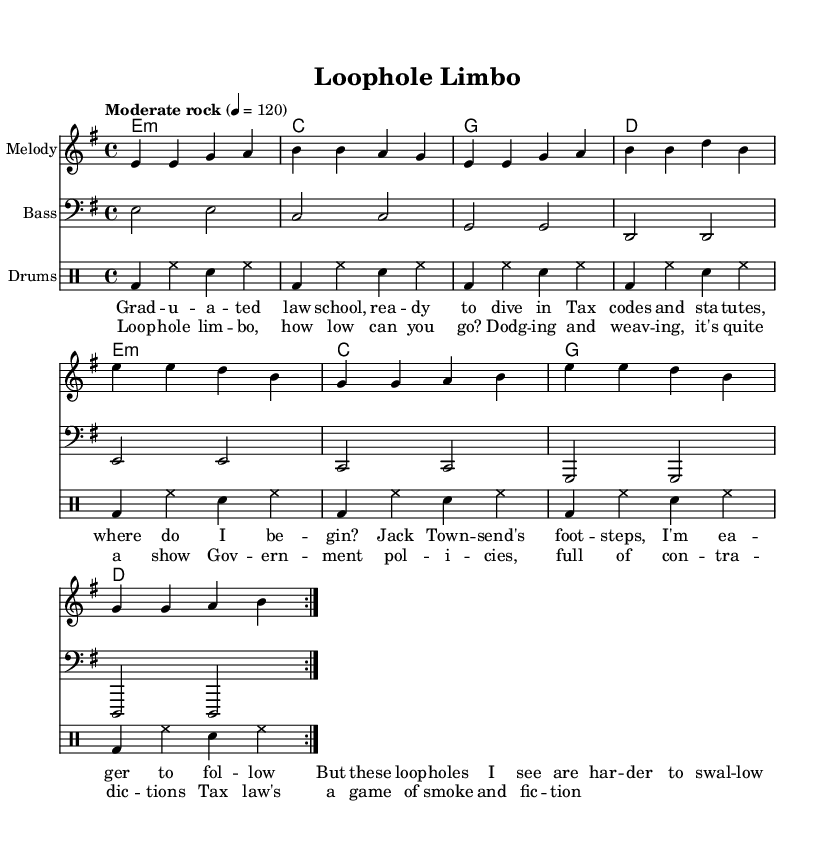What is the key signature of this music? The key signature shown in the music is E minor, which has one sharp (F#). This can be identified from the key signature notation at the beginning of the staff.
Answer: E minor What is the time signature of this piece? The time signature indicated in the sheet music is 4/4, which is shown at the beginning next to the key signature. This means there are four beats in a measure, and a quarter note gets one beat.
Answer: 4/4 What is the tempo marking for this song? The tempo marking is "Moderate rock," followed by a metronome indication of 120 beats per minute, which sets the pace of the piece. This is found at the top of the score section.
Answer: Moderate rock How many verses does the song have? The song has one verse, as indicated by the structure of the lyrics above the melody without any repetition or additional verses notated.
Answer: One verse Which lyrical section comes after the verse? After the verse, the lyrical section that follows is the chorus, as indicated in the layout where the verse is separated from the chorus lyrics.
Answer: Chorus How many times is the melody repeated? The melody section is marked with "repeat volta 2," indicating that the melody is played twice throughout the piece. This information can be deduced from the repeat symbols and the notation throughout the music.
Answer: Twice What is the primary theme of the lyrics? The primary theme is a critique of government and tax policies, as expressed through satirical lyrics about navigating tax law and loopholes. This can be inferred from the titles and the content of the lyrics provided in the score.
Answer: Critique of government and tax policies 